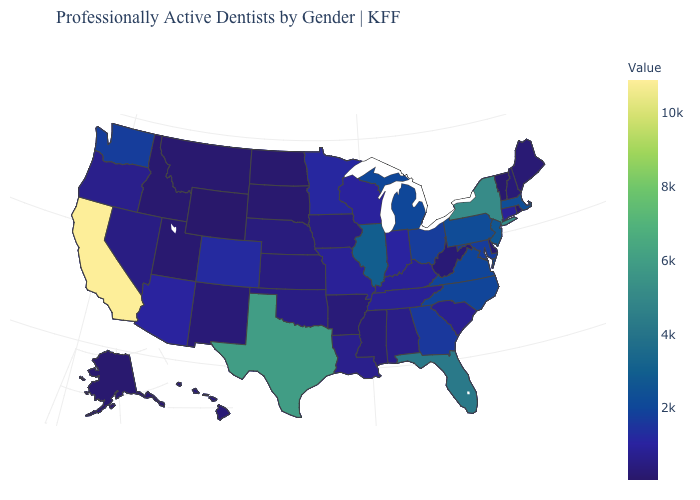Is the legend a continuous bar?
Answer briefly. Yes. Does Nevada have a lower value than Florida?
Concise answer only. Yes. Among the states that border South Carolina , which have the lowest value?
Quick response, please. Georgia. Among the states that border Virginia , does West Virginia have the lowest value?
Short answer required. Yes. Is the legend a continuous bar?
Be succinct. Yes. Does California have the highest value in the West?
Quick response, please. Yes. Which states have the lowest value in the USA?
Quick response, please. Wyoming. 